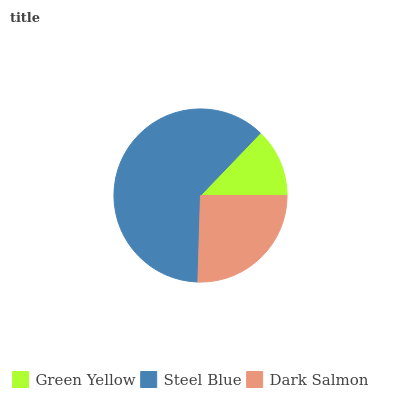Is Green Yellow the minimum?
Answer yes or no. Yes. Is Steel Blue the maximum?
Answer yes or no. Yes. Is Dark Salmon the minimum?
Answer yes or no. No. Is Dark Salmon the maximum?
Answer yes or no. No. Is Steel Blue greater than Dark Salmon?
Answer yes or no. Yes. Is Dark Salmon less than Steel Blue?
Answer yes or no. Yes. Is Dark Salmon greater than Steel Blue?
Answer yes or no. No. Is Steel Blue less than Dark Salmon?
Answer yes or no. No. Is Dark Salmon the high median?
Answer yes or no. Yes. Is Dark Salmon the low median?
Answer yes or no. Yes. Is Steel Blue the high median?
Answer yes or no. No. Is Green Yellow the low median?
Answer yes or no. No. 